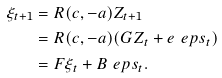<formula> <loc_0><loc_0><loc_500><loc_500>\xi _ { t + 1 } & = R ( c , - a ) Z _ { t + 1 } \\ & = R ( c , - a ) ( G Z _ { t } + e \ e p s _ { t } ) \\ & = F \xi _ { t } + B \ e p s _ { t } .</formula> 